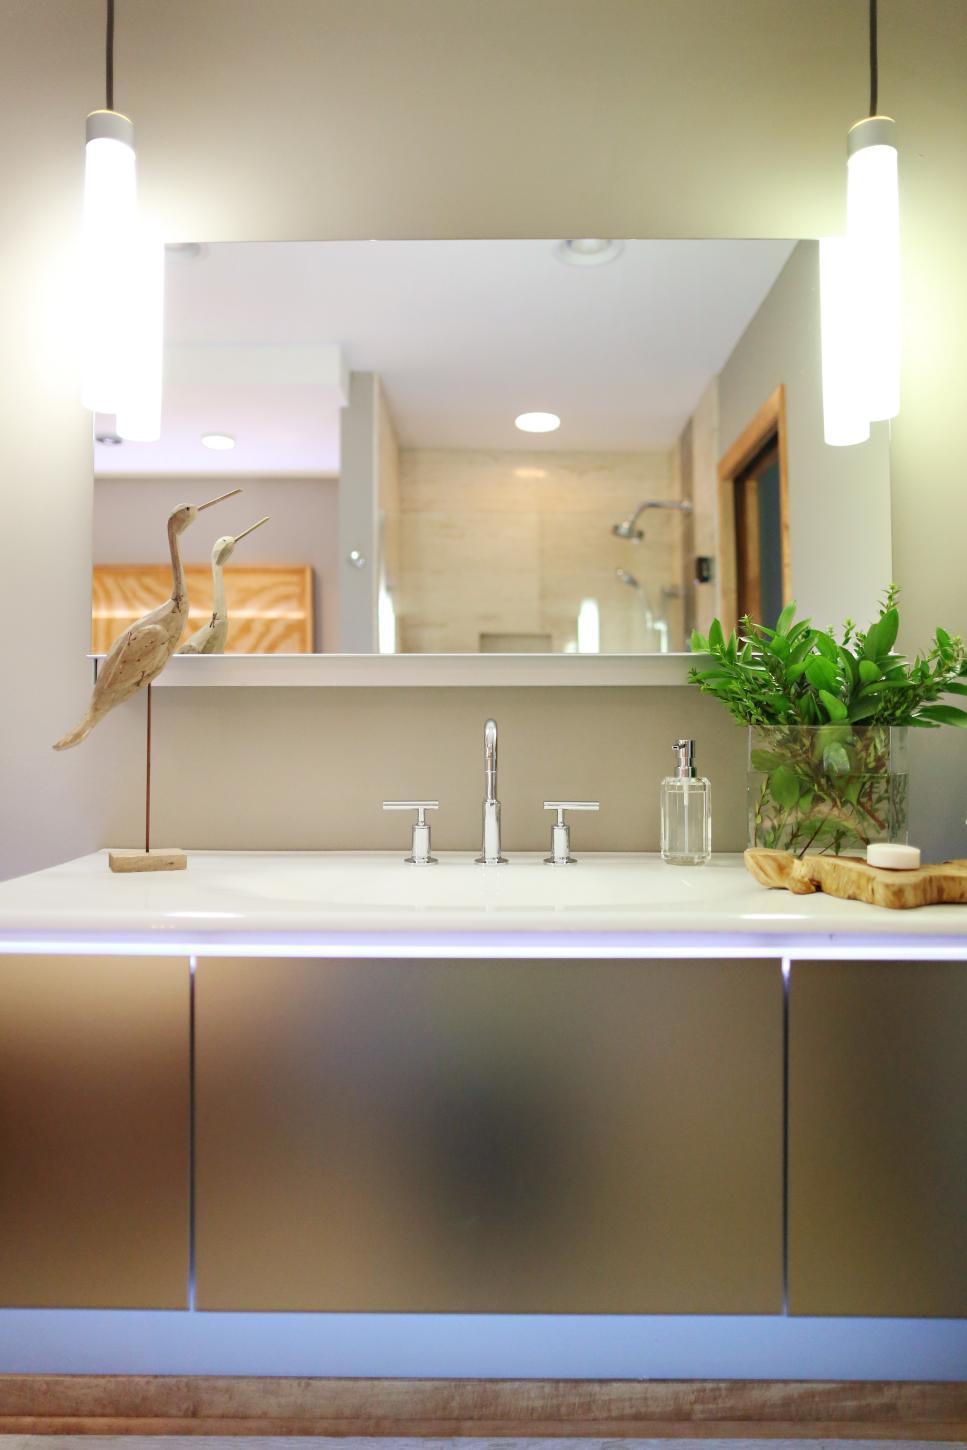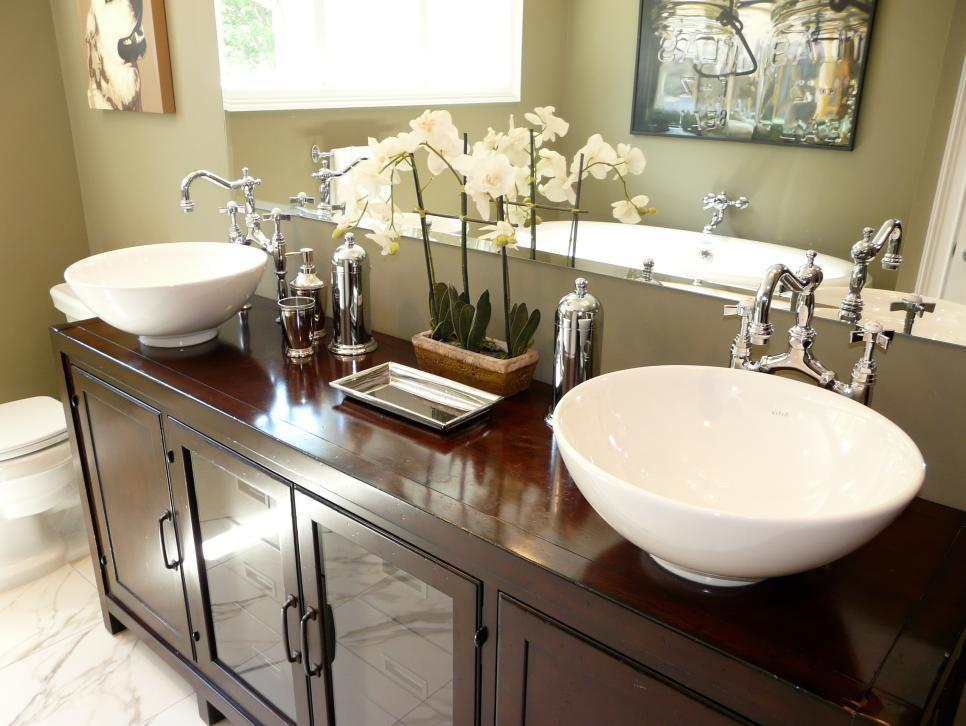The first image is the image on the left, the second image is the image on the right. Assess this claim about the two images: "Vanities in both images have an equal number of sinks.". Correct or not? Answer yes or no. No. The first image is the image on the left, the second image is the image on the right. Assess this claim about the two images: "An image includes a round white vessel sink.". Correct or not? Answer yes or no. Yes. The first image is the image on the left, the second image is the image on the right. Analyze the images presented: Is the assertion "The right image features at least one round white bowl-shaped sink atop a vanity." valid? Answer yes or no. Yes. 